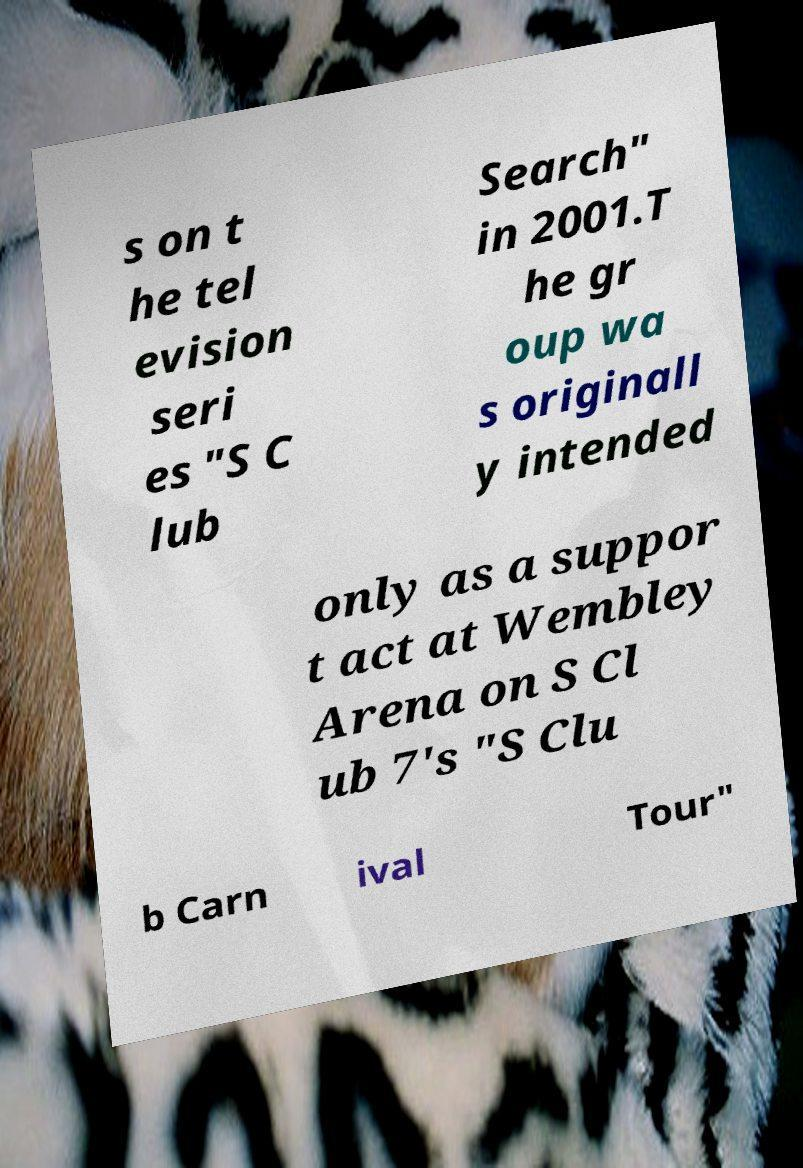Please read and relay the text visible in this image. What does it say? s on t he tel evision seri es "S C lub Search" in 2001.T he gr oup wa s originall y intended only as a suppor t act at Wembley Arena on S Cl ub 7's "S Clu b Carn ival Tour" 